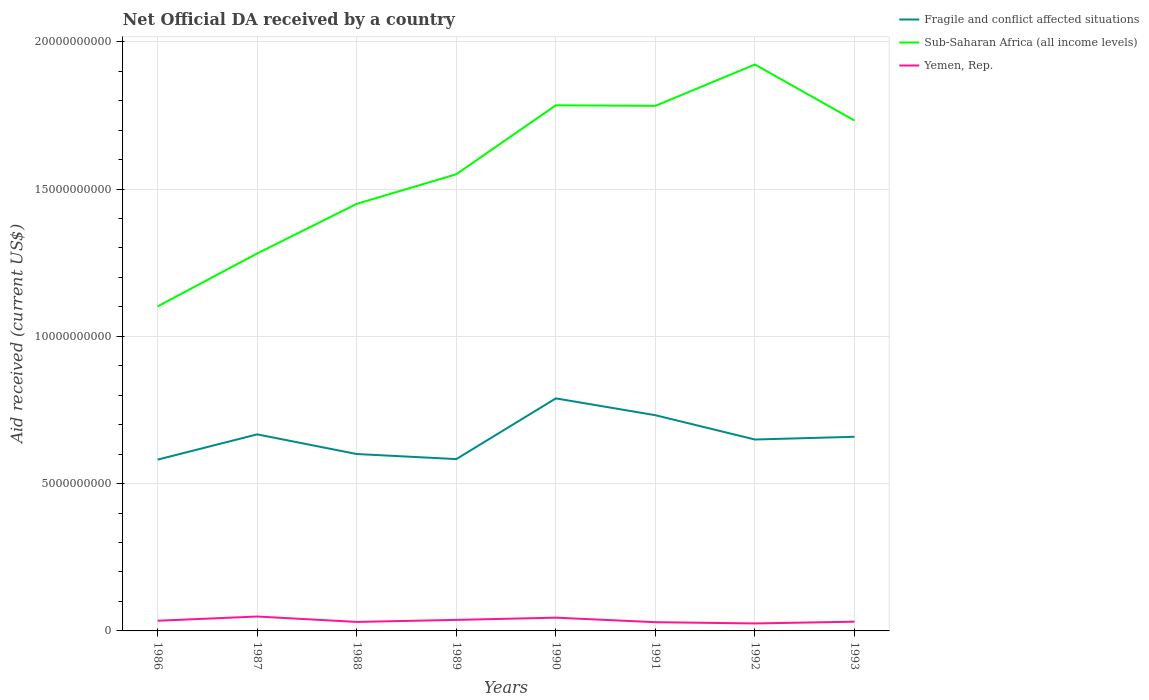How many different coloured lines are there?
Ensure brevity in your answer.  3. Does the line corresponding to Sub-Saharan Africa (all income levels) intersect with the line corresponding to Fragile and conflict affected situations?
Keep it short and to the point. No. Across all years, what is the maximum net official development assistance aid received in Yemen, Rep.?
Offer a terse response. 2.54e+08. What is the total net official development assistance aid received in Yemen, Rep. in the graph?
Offer a terse response. -2.85e+07. What is the difference between the highest and the second highest net official development assistance aid received in Fragile and conflict affected situations?
Your response must be concise. 2.08e+09. How many lines are there?
Provide a succinct answer. 3. Are the values on the major ticks of Y-axis written in scientific E-notation?
Offer a very short reply. No. Does the graph contain grids?
Your answer should be very brief. Yes. Where does the legend appear in the graph?
Make the answer very short. Top right. How many legend labels are there?
Your answer should be very brief. 3. What is the title of the graph?
Your response must be concise. Net Official DA received by a country. What is the label or title of the X-axis?
Make the answer very short. Years. What is the label or title of the Y-axis?
Keep it short and to the point. Aid received (current US$). What is the Aid received (current US$) in Fragile and conflict affected situations in 1986?
Ensure brevity in your answer.  5.81e+09. What is the Aid received (current US$) in Sub-Saharan Africa (all income levels) in 1986?
Ensure brevity in your answer.  1.10e+1. What is the Aid received (current US$) of Yemen, Rep. in 1986?
Give a very brief answer. 3.46e+08. What is the Aid received (current US$) in Fragile and conflict affected situations in 1987?
Offer a very short reply. 6.67e+09. What is the Aid received (current US$) of Sub-Saharan Africa (all income levels) in 1987?
Make the answer very short. 1.28e+1. What is the Aid received (current US$) of Yemen, Rep. in 1987?
Your answer should be compact. 4.89e+08. What is the Aid received (current US$) of Fragile and conflict affected situations in 1988?
Your response must be concise. 6.00e+09. What is the Aid received (current US$) of Sub-Saharan Africa (all income levels) in 1988?
Keep it short and to the point. 1.45e+1. What is the Aid received (current US$) of Yemen, Rep. in 1988?
Offer a very short reply. 3.05e+08. What is the Aid received (current US$) in Fragile and conflict affected situations in 1989?
Provide a succinct answer. 5.83e+09. What is the Aid received (current US$) in Sub-Saharan Africa (all income levels) in 1989?
Provide a succinct answer. 1.55e+1. What is the Aid received (current US$) of Yemen, Rep. in 1989?
Your answer should be very brief. 3.74e+08. What is the Aid received (current US$) of Fragile and conflict affected situations in 1990?
Provide a succinct answer. 7.89e+09. What is the Aid received (current US$) of Sub-Saharan Africa (all income levels) in 1990?
Your answer should be compact. 1.78e+1. What is the Aid received (current US$) in Yemen, Rep. in 1990?
Ensure brevity in your answer.  4.50e+08. What is the Aid received (current US$) in Fragile and conflict affected situations in 1991?
Your response must be concise. 7.32e+09. What is the Aid received (current US$) in Sub-Saharan Africa (all income levels) in 1991?
Make the answer very short. 1.78e+1. What is the Aid received (current US$) of Yemen, Rep. in 1991?
Your response must be concise. 2.96e+08. What is the Aid received (current US$) in Fragile and conflict affected situations in 1992?
Offer a very short reply. 6.50e+09. What is the Aid received (current US$) of Sub-Saharan Africa (all income levels) in 1992?
Give a very brief answer. 1.92e+1. What is the Aid received (current US$) of Yemen, Rep. in 1992?
Your answer should be very brief. 2.54e+08. What is the Aid received (current US$) in Fragile and conflict affected situations in 1993?
Your answer should be compact. 6.59e+09. What is the Aid received (current US$) in Sub-Saharan Africa (all income levels) in 1993?
Your answer should be very brief. 1.73e+1. What is the Aid received (current US$) in Yemen, Rep. in 1993?
Give a very brief answer. 3.13e+08. Across all years, what is the maximum Aid received (current US$) of Fragile and conflict affected situations?
Provide a succinct answer. 7.89e+09. Across all years, what is the maximum Aid received (current US$) of Sub-Saharan Africa (all income levels)?
Offer a terse response. 1.92e+1. Across all years, what is the maximum Aid received (current US$) in Yemen, Rep.?
Offer a very short reply. 4.89e+08. Across all years, what is the minimum Aid received (current US$) in Fragile and conflict affected situations?
Provide a succinct answer. 5.81e+09. Across all years, what is the minimum Aid received (current US$) in Sub-Saharan Africa (all income levels)?
Your answer should be compact. 1.10e+1. Across all years, what is the minimum Aid received (current US$) in Yemen, Rep.?
Make the answer very short. 2.54e+08. What is the total Aid received (current US$) of Fragile and conflict affected situations in the graph?
Your response must be concise. 5.26e+1. What is the total Aid received (current US$) of Sub-Saharan Africa (all income levels) in the graph?
Provide a succinct answer. 1.26e+11. What is the total Aid received (current US$) of Yemen, Rep. in the graph?
Offer a very short reply. 2.83e+09. What is the difference between the Aid received (current US$) in Fragile and conflict affected situations in 1986 and that in 1987?
Your answer should be compact. -8.57e+08. What is the difference between the Aid received (current US$) of Sub-Saharan Africa (all income levels) in 1986 and that in 1987?
Offer a terse response. -1.80e+09. What is the difference between the Aid received (current US$) of Yemen, Rep. in 1986 and that in 1987?
Your response must be concise. -1.43e+08. What is the difference between the Aid received (current US$) of Fragile and conflict affected situations in 1986 and that in 1988?
Make the answer very short. -1.89e+08. What is the difference between the Aid received (current US$) in Sub-Saharan Africa (all income levels) in 1986 and that in 1988?
Ensure brevity in your answer.  -3.48e+09. What is the difference between the Aid received (current US$) of Yemen, Rep. in 1986 and that in 1988?
Ensure brevity in your answer.  4.05e+07. What is the difference between the Aid received (current US$) of Fragile and conflict affected situations in 1986 and that in 1989?
Ensure brevity in your answer.  -1.72e+07. What is the difference between the Aid received (current US$) in Sub-Saharan Africa (all income levels) in 1986 and that in 1989?
Provide a succinct answer. -4.48e+09. What is the difference between the Aid received (current US$) in Yemen, Rep. in 1986 and that in 1989?
Your answer should be compact. -2.85e+07. What is the difference between the Aid received (current US$) of Fragile and conflict affected situations in 1986 and that in 1990?
Ensure brevity in your answer.  -2.08e+09. What is the difference between the Aid received (current US$) in Sub-Saharan Africa (all income levels) in 1986 and that in 1990?
Your answer should be very brief. -6.83e+09. What is the difference between the Aid received (current US$) in Yemen, Rep. in 1986 and that in 1990?
Keep it short and to the point. -1.04e+08. What is the difference between the Aid received (current US$) of Fragile and conflict affected situations in 1986 and that in 1991?
Give a very brief answer. -1.51e+09. What is the difference between the Aid received (current US$) of Sub-Saharan Africa (all income levels) in 1986 and that in 1991?
Your response must be concise. -6.81e+09. What is the difference between the Aid received (current US$) in Yemen, Rep. in 1986 and that in 1991?
Your answer should be very brief. 4.95e+07. What is the difference between the Aid received (current US$) of Fragile and conflict affected situations in 1986 and that in 1992?
Provide a short and direct response. -6.82e+08. What is the difference between the Aid received (current US$) in Sub-Saharan Africa (all income levels) in 1986 and that in 1992?
Offer a terse response. -8.21e+09. What is the difference between the Aid received (current US$) in Yemen, Rep. in 1986 and that in 1992?
Your response must be concise. 9.20e+07. What is the difference between the Aid received (current US$) in Fragile and conflict affected situations in 1986 and that in 1993?
Ensure brevity in your answer.  -7.75e+08. What is the difference between the Aid received (current US$) in Sub-Saharan Africa (all income levels) in 1986 and that in 1993?
Give a very brief answer. -6.31e+09. What is the difference between the Aid received (current US$) in Yemen, Rep. in 1986 and that in 1993?
Your answer should be compact. 3.26e+07. What is the difference between the Aid received (current US$) in Fragile and conflict affected situations in 1987 and that in 1988?
Make the answer very short. 6.68e+08. What is the difference between the Aid received (current US$) in Sub-Saharan Africa (all income levels) in 1987 and that in 1988?
Give a very brief answer. -1.68e+09. What is the difference between the Aid received (current US$) of Yemen, Rep. in 1987 and that in 1988?
Offer a terse response. 1.83e+08. What is the difference between the Aid received (current US$) in Fragile and conflict affected situations in 1987 and that in 1989?
Offer a terse response. 8.40e+08. What is the difference between the Aid received (current US$) in Sub-Saharan Africa (all income levels) in 1987 and that in 1989?
Ensure brevity in your answer.  -2.69e+09. What is the difference between the Aid received (current US$) in Yemen, Rep. in 1987 and that in 1989?
Provide a short and direct response. 1.14e+08. What is the difference between the Aid received (current US$) in Fragile and conflict affected situations in 1987 and that in 1990?
Ensure brevity in your answer.  -1.22e+09. What is the difference between the Aid received (current US$) in Sub-Saharan Africa (all income levels) in 1987 and that in 1990?
Offer a terse response. -5.03e+09. What is the difference between the Aid received (current US$) in Yemen, Rep. in 1987 and that in 1990?
Your response must be concise. 3.89e+07. What is the difference between the Aid received (current US$) in Fragile and conflict affected situations in 1987 and that in 1991?
Ensure brevity in your answer.  -6.50e+08. What is the difference between the Aid received (current US$) of Sub-Saharan Africa (all income levels) in 1987 and that in 1991?
Make the answer very short. -5.01e+09. What is the difference between the Aid received (current US$) in Yemen, Rep. in 1987 and that in 1991?
Make the answer very short. 1.92e+08. What is the difference between the Aid received (current US$) in Fragile and conflict affected situations in 1987 and that in 1992?
Your response must be concise. 1.75e+08. What is the difference between the Aid received (current US$) of Sub-Saharan Africa (all income levels) in 1987 and that in 1992?
Ensure brevity in your answer.  -6.41e+09. What is the difference between the Aid received (current US$) of Yemen, Rep. in 1987 and that in 1992?
Your answer should be compact. 2.35e+08. What is the difference between the Aid received (current US$) in Fragile and conflict affected situations in 1987 and that in 1993?
Give a very brief answer. 8.20e+07. What is the difference between the Aid received (current US$) of Sub-Saharan Africa (all income levels) in 1987 and that in 1993?
Ensure brevity in your answer.  -4.51e+09. What is the difference between the Aid received (current US$) in Yemen, Rep. in 1987 and that in 1993?
Give a very brief answer. 1.76e+08. What is the difference between the Aid received (current US$) in Fragile and conflict affected situations in 1988 and that in 1989?
Offer a terse response. 1.72e+08. What is the difference between the Aid received (current US$) of Sub-Saharan Africa (all income levels) in 1988 and that in 1989?
Provide a succinct answer. -1.00e+09. What is the difference between the Aid received (current US$) of Yemen, Rep. in 1988 and that in 1989?
Your response must be concise. -6.89e+07. What is the difference between the Aid received (current US$) in Fragile and conflict affected situations in 1988 and that in 1990?
Your answer should be very brief. -1.89e+09. What is the difference between the Aid received (current US$) of Sub-Saharan Africa (all income levels) in 1988 and that in 1990?
Give a very brief answer. -3.35e+09. What is the difference between the Aid received (current US$) in Yemen, Rep. in 1988 and that in 1990?
Your answer should be compact. -1.44e+08. What is the difference between the Aid received (current US$) in Fragile and conflict affected situations in 1988 and that in 1991?
Ensure brevity in your answer.  -1.32e+09. What is the difference between the Aid received (current US$) of Sub-Saharan Africa (all income levels) in 1988 and that in 1991?
Make the answer very short. -3.33e+09. What is the difference between the Aid received (current US$) of Yemen, Rep. in 1988 and that in 1991?
Make the answer very short. 9.00e+06. What is the difference between the Aid received (current US$) of Fragile and conflict affected situations in 1988 and that in 1992?
Offer a terse response. -4.93e+08. What is the difference between the Aid received (current US$) in Sub-Saharan Africa (all income levels) in 1988 and that in 1992?
Offer a terse response. -4.73e+09. What is the difference between the Aid received (current US$) in Yemen, Rep. in 1988 and that in 1992?
Keep it short and to the point. 5.16e+07. What is the difference between the Aid received (current US$) in Fragile and conflict affected situations in 1988 and that in 1993?
Provide a short and direct response. -5.86e+08. What is the difference between the Aid received (current US$) of Sub-Saharan Africa (all income levels) in 1988 and that in 1993?
Ensure brevity in your answer.  -2.83e+09. What is the difference between the Aid received (current US$) in Yemen, Rep. in 1988 and that in 1993?
Offer a terse response. -7.83e+06. What is the difference between the Aid received (current US$) in Fragile and conflict affected situations in 1989 and that in 1990?
Offer a terse response. -2.06e+09. What is the difference between the Aid received (current US$) of Sub-Saharan Africa (all income levels) in 1989 and that in 1990?
Provide a succinct answer. -2.34e+09. What is the difference between the Aid received (current US$) of Yemen, Rep. in 1989 and that in 1990?
Give a very brief answer. -7.56e+07. What is the difference between the Aid received (current US$) in Fragile and conflict affected situations in 1989 and that in 1991?
Provide a succinct answer. -1.49e+09. What is the difference between the Aid received (current US$) of Sub-Saharan Africa (all income levels) in 1989 and that in 1991?
Your response must be concise. -2.32e+09. What is the difference between the Aid received (current US$) in Yemen, Rep. in 1989 and that in 1991?
Ensure brevity in your answer.  7.79e+07. What is the difference between the Aid received (current US$) of Fragile and conflict affected situations in 1989 and that in 1992?
Your answer should be very brief. -6.65e+08. What is the difference between the Aid received (current US$) in Sub-Saharan Africa (all income levels) in 1989 and that in 1992?
Your answer should be very brief. -3.72e+09. What is the difference between the Aid received (current US$) in Yemen, Rep. in 1989 and that in 1992?
Ensure brevity in your answer.  1.21e+08. What is the difference between the Aid received (current US$) in Fragile and conflict affected situations in 1989 and that in 1993?
Provide a succinct answer. -7.58e+08. What is the difference between the Aid received (current US$) of Sub-Saharan Africa (all income levels) in 1989 and that in 1993?
Make the answer very short. -1.82e+09. What is the difference between the Aid received (current US$) of Yemen, Rep. in 1989 and that in 1993?
Offer a terse response. 6.11e+07. What is the difference between the Aid received (current US$) of Fragile and conflict affected situations in 1990 and that in 1991?
Offer a very short reply. 5.70e+08. What is the difference between the Aid received (current US$) of Sub-Saharan Africa (all income levels) in 1990 and that in 1991?
Make the answer very short. 1.91e+07. What is the difference between the Aid received (current US$) in Yemen, Rep. in 1990 and that in 1991?
Your answer should be very brief. 1.53e+08. What is the difference between the Aid received (current US$) in Fragile and conflict affected situations in 1990 and that in 1992?
Your response must be concise. 1.40e+09. What is the difference between the Aid received (current US$) in Sub-Saharan Africa (all income levels) in 1990 and that in 1992?
Provide a succinct answer. -1.38e+09. What is the difference between the Aid received (current US$) in Yemen, Rep. in 1990 and that in 1992?
Keep it short and to the point. 1.96e+08. What is the difference between the Aid received (current US$) of Fragile and conflict affected situations in 1990 and that in 1993?
Provide a short and direct response. 1.30e+09. What is the difference between the Aid received (current US$) in Sub-Saharan Africa (all income levels) in 1990 and that in 1993?
Keep it short and to the point. 5.17e+08. What is the difference between the Aid received (current US$) in Yemen, Rep. in 1990 and that in 1993?
Your response must be concise. 1.37e+08. What is the difference between the Aid received (current US$) of Fragile and conflict affected situations in 1991 and that in 1992?
Make the answer very short. 8.25e+08. What is the difference between the Aid received (current US$) in Sub-Saharan Africa (all income levels) in 1991 and that in 1992?
Your answer should be very brief. -1.40e+09. What is the difference between the Aid received (current US$) of Yemen, Rep. in 1991 and that in 1992?
Make the answer very short. 4.26e+07. What is the difference between the Aid received (current US$) of Fragile and conflict affected situations in 1991 and that in 1993?
Offer a terse response. 7.32e+08. What is the difference between the Aid received (current US$) in Sub-Saharan Africa (all income levels) in 1991 and that in 1993?
Give a very brief answer. 4.98e+08. What is the difference between the Aid received (current US$) of Yemen, Rep. in 1991 and that in 1993?
Your response must be concise. -1.68e+07. What is the difference between the Aid received (current US$) of Fragile and conflict affected situations in 1992 and that in 1993?
Keep it short and to the point. -9.26e+07. What is the difference between the Aid received (current US$) of Sub-Saharan Africa (all income levels) in 1992 and that in 1993?
Your answer should be compact. 1.90e+09. What is the difference between the Aid received (current US$) of Yemen, Rep. in 1992 and that in 1993?
Your response must be concise. -5.94e+07. What is the difference between the Aid received (current US$) in Fragile and conflict affected situations in 1986 and the Aid received (current US$) in Sub-Saharan Africa (all income levels) in 1987?
Provide a succinct answer. -7.00e+09. What is the difference between the Aid received (current US$) of Fragile and conflict affected situations in 1986 and the Aid received (current US$) of Yemen, Rep. in 1987?
Your response must be concise. 5.33e+09. What is the difference between the Aid received (current US$) in Sub-Saharan Africa (all income levels) in 1986 and the Aid received (current US$) in Yemen, Rep. in 1987?
Your answer should be very brief. 1.05e+1. What is the difference between the Aid received (current US$) of Fragile and conflict affected situations in 1986 and the Aid received (current US$) of Sub-Saharan Africa (all income levels) in 1988?
Keep it short and to the point. -8.68e+09. What is the difference between the Aid received (current US$) of Fragile and conflict affected situations in 1986 and the Aid received (current US$) of Yemen, Rep. in 1988?
Your answer should be compact. 5.51e+09. What is the difference between the Aid received (current US$) of Sub-Saharan Africa (all income levels) in 1986 and the Aid received (current US$) of Yemen, Rep. in 1988?
Offer a very short reply. 1.07e+1. What is the difference between the Aid received (current US$) in Fragile and conflict affected situations in 1986 and the Aid received (current US$) in Sub-Saharan Africa (all income levels) in 1989?
Keep it short and to the point. -9.69e+09. What is the difference between the Aid received (current US$) of Fragile and conflict affected situations in 1986 and the Aid received (current US$) of Yemen, Rep. in 1989?
Make the answer very short. 5.44e+09. What is the difference between the Aid received (current US$) in Sub-Saharan Africa (all income levels) in 1986 and the Aid received (current US$) in Yemen, Rep. in 1989?
Provide a succinct answer. 1.06e+1. What is the difference between the Aid received (current US$) in Fragile and conflict affected situations in 1986 and the Aid received (current US$) in Sub-Saharan Africa (all income levels) in 1990?
Offer a very short reply. -1.20e+1. What is the difference between the Aid received (current US$) in Fragile and conflict affected situations in 1986 and the Aid received (current US$) in Yemen, Rep. in 1990?
Your answer should be very brief. 5.37e+09. What is the difference between the Aid received (current US$) of Sub-Saharan Africa (all income levels) in 1986 and the Aid received (current US$) of Yemen, Rep. in 1990?
Ensure brevity in your answer.  1.06e+1. What is the difference between the Aid received (current US$) of Fragile and conflict affected situations in 1986 and the Aid received (current US$) of Sub-Saharan Africa (all income levels) in 1991?
Ensure brevity in your answer.  -1.20e+1. What is the difference between the Aid received (current US$) of Fragile and conflict affected situations in 1986 and the Aid received (current US$) of Yemen, Rep. in 1991?
Your answer should be very brief. 5.52e+09. What is the difference between the Aid received (current US$) of Sub-Saharan Africa (all income levels) in 1986 and the Aid received (current US$) of Yemen, Rep. in 1991?
Offer a very short reply. 1.07e+1. What is the difference between the Aid received (current US$) of Fragile and conflict affected situations in 1986 and the Aid received (current US$) of Sub-Saharan Africa (all income levels) in 1992?
Provide a succinct answer. -1.34e+1. What is the difference between the Aid received (current US$) in Fragile and conflict affected situations in 1986 and the Aid received (current US$) in Yemen, Rep. in 1992?
Your answer should be very brief. 5.56e+09. What is the difference between the Aid received (current US$) in Sub-Saharan Africa (all income levels) in 1986 and the Aid received (current US$) in Yemen, Rep. in 1992?
Your answer should be compact. 1.08e+1. What is the difference between the Aid received (current US$) in Fragile and conflict affected situations in 1986 and the Aid received (current US$) in Sub-Saharan Africa (all income levels) in 1993?
Keep it short and to the point. -1.15e+1. What is the difference between the Aid received (current US$) of Fragile and conflict affected situations in 1986 and the Aid received (current US$) of Yemen, Rep. in 1993?
Give a very brief answer. 5.50e+09. What is the difference between the Aid received (current US$) in Sub-Saharan Africa (all income levels) in 1986 and the Aid received (current US$) in Yemen, Rep. in 1993?
Your answer should be very brief. 1.07e+1. What is the difference between the Aid received (current US$) of Fragile and conflict affected situations in 1987 and the Aid received (current US$) of Sub-Saharan Africa (all income levels) in 1988?
Ensure brevity in your answer.  -7.82e+09. What is the difference between the Aid received (current US$) in Fragile and conflict affected situations in 1987 and the Aid received (current US$) in Yemen, Rep. in 1988?
Provide a succinct answer. 6.37e+09. What is the difference between the Aid received (current US$) in Sub-Saharan Africa (all income levels) in 1987 and the Aid received (current US$) in Yemen, Rep. in 1988?
Ensure brevity in your answer.  1.25e+1. What is the difference between the Aid received (current US$) of Fragile and conflict affected situations in 1987 and the Aid received (current US$) of Sub-Saharan Africa (all income levels) in 1989?
Offer a terse response. -8.83e+09. What is the difference between the Aid received (current US$) in Fragile and conflict affected situations in 1987 and the Aid received (current US$) in Yemen, Rep. in 1989?
Provide a short and direct response. 6.30e+09. What is the difference between the Aid received (current US$) of Sub-Saharan Africa (all income levels) in 1987 and the Aid received (current US$) of Yemen, Rep. in 1989?
Offer a terse response. 1.24e+1. What is the difference between the Aid received (current US$) of Fragile and conflict affected situations in 1987 and the Aid received (current US$) of Sub-Saharan Africa (all income levels) in 1990?
Your answer should be compact. -1.12e+1. What is the difference between the Aid received (current US$) in Fragile and conflict affected situations in 1987 and the Aid received (current US$) in Yemen, Rep. in 1990?
Keep it short and to the point. 6.22e+09. What is the difference between the Aid received (current US$) of Sub-Saharan Africa (all income levels) in 1987 and the Aid received (current US$) of Yemen, Rep. in 1990?
Your response must be concise. 1.24e+1. What is the difference between the Aid received (current US$) in Fragile and conflict affected situations in 1987 and the Aid received (current US$) in Sub-Saharan Africa (all income levels) in 1991?
Provide a succinct answer. -1.12e+1. What is the difference between the Aid received (current US$) of Fragile and conflict affected situations in 1987 and the Aid received (current US$) of Yemen, Rep. in 1991?
Ensure brevity in your answer.  6.38e+09. What is the difference between the Aid received (current US$) in Sub-Saharan Africa (all income levels) in 1987 and the Aid received (current US$) in Yemen, Rep. in 1991?
Your response must be concise. 1.25e+1. What is the difference between the Aid received (current US$) in Fragile and conflict affected situations in 1987 and the Aid received (current US$) in Sub-Saharan Africa (all income levels) in 1992?
Provide a short and direct response. -1.26e+1. What is the difference between the Aid received (current US$) in Fragile and conflict affected situations in 1987 and the Aid received (current US$) in Yemen, Rep. in 1992?
Offer a terse response. 6.42e+09. What is the difference between the Aid received (current US$) in Sub-Saharan Africa (all income levels) in 1987 and the Aid received (current US$) in Yemen, Rep. in 1992?
Keep it short and to the point. 1.26e+1. What is the difference between the Aid received (current US$) in Fragile and conflict affected situations in 1987 and the Aid received (current US$) in Sub-Saharan Africa (all income levels) in 1993?
Your response must be concise. -1.07e+1. What is the difference between the Aid received (current US$) in Fragile and conflict affected situations in 1987 and the Aid received (current US$) in Yemen, Rep. in 1993?
Offer a terse response. 6.36e+09. What is the difference between the Aid received (current US$) of Sub-Saharan Africa (all income levels) in 1987 and the Aid received (current US$) of Yemen, Rep. in 1993?
Your answer should be compact. 1.25e+1. What is the difference between the Aid received (current US$) in Fragile and conflict affected situations in 1988 and the Aid received (current US$) in Sub-Saharan Africa (all income levels) in 1989?
Your answer should be very brief. -9.50e+09. What is the difference between the Aid received (current US$) of Fragile and conflict affected situations in 1988 and the Aid received (current US$) of Yemen, Rep. in 1989?
Make the answer very short. 5.63e+09. What is the difference between the Aid received (current US$) of Sub-Saharan Africa (all income levels) in 1988 and the Aid received (current US$) of Yemen, Rep. in 1989?
Offer a terse response. 1.41e+1. What is the difference between the Aid received (current US$) of Fragile and conflict affected situations in 1988 and the Aid received (current US$) of Sub-Saharan Africa (all income levels) in 1990?
Make the answer very short. -1.18e+1. What is the difference between the Aid received (current US$) in Fragile and conflict affected situations in 1988 and the Aid received (current US$) in Yemen, Rep. in 1990?
Your answer should be compact. 5.55e+09. What is the difference between the Aid received (current US$) in Sub-Saharan Africa (all income levels) in 1988 and the Aid received (current US$) in Yemen, Rep. in 1990?
Your response must be concise. 1.40e+1. What is the difference between the Aid received (current US$) in Fragile and conflict affected situations in 1988 and the Aid received (current US$) in Sub-Saharan Africa (all income levels) in 1991?
Provide a succinct answer. -1.18e+1. What is the difference between the Aid received (current US$) in Fragile and conflict affected situations in 1988 and the Aid received (current US$) in Yemen, Rep. in 1991?
Ensure brevity in your answer.  5.71e+09. What is the difference between the Aid received (current US$) of Sub-Saharan Africa (all income levels) in 1988 and the Aid received (current US$) of Yemen, Rep. in 1991?
Your response must be concise. 1.42e+1. What is the difference between the Aid received (current US$) in Fragile and conflict affected situations in 1988 and the Aid received (current US$) in Sub-Saharan Africa (all income levels) in 1992?
Your answer should be compact. -1.32e+1. What is the difference between the Aid received (current US$) of Fragile and conflict affected situations in 1988 and the Aid received (current US$) of Yemen, Rep. in 1992?
Ensure brevity in your answer.  5.75e+09. What is the difference between the Aid received (current US$) of Sub-Saharan Africa (all income levels) in 1988 and the Aid received (current US$) of Yemen, Rep. in 1992?
Make the answer very short. 1.42e+1. What is the difference between the Aid received (current US$) in Fragile and conflict affected situations in 1988 and the Aid received (current US$) in Sub-Saharan Africa (all income levels) in 1993?
Provide a short and direct response. -1.13e+1. What is the difference between the Aid received (current US$) of Fragile and conflict affected situations in 1988 and the Aid received (current US$) of Yemen, Rep. in 1993?
Ensure brevity in your answer.  5.69e+09. What is the difference between the Aid received (current US$) in Sub-Saharan Africa (all income levels) in 1988 and the Aid received (current US$) in Yemen, Rep. in 1993?
Give a very brief answer. 1.42e+1. What is the difference between the Aid received (current US$) in Fragile and conflict affected situations in 1989 and the Aid received (current US$) in Sub-Saharan Africa (all income levels) in 1990?
Offer a very short reply. -1.20e+1. What is the difference between the Aid received (current US$) of Fragile and conflict affected situations in 1989 and the Aid received (current US$) of Yemen, Rep. in 1990?
Make the answer very short. 5.38e+09. What is the difference between the Aid received (current US$) of Sub-Saharan Africa (all income levels) in 1989 and the Aid received (current US$) of Yemen, Rep. in 1990?
Offer a terse response. 1.51e+1. What is the difference between the Aid received (current US$) in Fragile and conflict affected situations in 1989 and the Aid received (current US$) in Sub-Saharan Africa (all income levels) in 1991?
Your answer should be compact. -1.20e+1. What is the difference between the Aid received (current US$) of Fragile and conflict affected situations in 1989 and the Aid received (current US$) of Yemen, Rep. in 1991?
Give a very brief answer. 5.54e+09. What is the difference between the Aid received (current US$) in Sub-Saharan Africa (all income levels) in 1989 and the Aid received (current US$) in Yemen, Rep. in 1991?
Provide a short and direct response. 1.52e+1. What is the difference between the Aid received (current US$) in Fragile and conflict affected situations in 1989 and the Aid received (current US$) in Sub-Saharan Africa (all income levels) in 1992?
Offer a terse response. -1.34e+1. What is the difference between the Aid received (current US$) of Fragile and conflict affected situations in 1989 and the Aid received (current US$) of Yemen, Rep. in 1992?
Offer a terse response. 5.58e+09. What is the difference between the Aid received (current US$) in Sub-Saharan Africa (all income levels) in 1989 and the Aid received (current US$) in Yemen, Rep. in 1992?
Keep it short and to the point. 1.52e+1. What is the difference between the Aid received (current US$) in Fragile and conflict affected situations in 1989 and the Aid received (current US$) in Sub-Saharan Africa (all income levels) in 1993?
Provide a short and direct response. -1.15e+1. What is the difference between the Aid received (current US$) in Fragile and conflict affected situations in 1989 and the Aid received (current US$) in Yemen, Rep. in 1993?
Your response must be concise. 5.52e+09. What is the difference between the Aid received (current US$) in Sub-Saharan Africa (all income levels) in 1989 and the Aid received (current US$) in Yemen, Rep. in 1993?
Ensure brevity in your answer.  1.52e+1. What is the difference between the Aid received (current US$) in Fragile and conflict affected situations in 1990 and the Aid received (current US$) in Sub-Saharan Africa (all income levels) in 1991?
Your response must be concise. -9.93e+09. What is the difference between the Aid received (current US$) in Fragile and conflict affected situations in 1990 and the Aid received (current US$) in Yemen, Rep. in 1991?
Make the answer very short. 7.60e+09. What is the difference between the Aid received (current US$) in Sub-Saharan Africa (all income levels) in 1990 and the Aid received (current US$) in Yemen, Rep. in 1991?
Keep it short and to the point. 1.75e+1. What is the difference between the Aid received (current US$) in Fragile and conflict affected situations in 1990 and the Aid received (current US$) in Sub-Saharan Africa (all income levels) in 1992?
Your response must be concise. -1.13e+1. What is the difference between the Aid received (current US$) of Fragile and conflict affected situations in 1990 and the Aid received (current US$) of Yemen, Rep. in 1992?
Your answer should be compact. 7.64e+09. What is the difference between the Aid received (current US$) in Sub-Saharan Africa (all income levels) in 1990 and the Aid received (current US$) in Yemen, Rep. in 1992?
Provide a succinct answer. 1.76e+1. What is the difference between the Aid received (current US$) in Fragile and conflict affected situations in 1990 and the Aid received (current US$) in Sub-Saharan Africa (all income levels) in 1993?
Offer a terse response. -9.43e+09. What is the difference between the Aid received (current US$) in Fragile and conflict affected situations in 1990 and the Aid received (current US$) in Yemen, Rep. in 1993?
Keep it short and to the point. 7.58e+09. What is the difference between the Aid received (current US$) in Sub-Saharan Africa (all income levels) in 1990 and the Aid received (current US$) in Yemen, Rep. in 1993?
Provide a succinct answer. 1.75e+1. What is the difference between the Aid received (current US$) of Fragile and conflict affected situations in 1991 and the Aid received (current US$) of Sub-Saharan Africa (all income levels) in 1992?
Keep it short and to the point. -1.19e+1. What is the difference between the Aid received (current US$) of Fragile and conflict affected situations in 1991 and the Aid received (current US$) of Yemen, Rep. in 1992?
Offer a terse response. 7.07e+09. What is the difference between the Aid received (current US$) of Sub-Saharan Africa (all income levels) in 1991 and the Aid received (current US$) of Yemen, Rep. in 1992?
Provide a short and direct response. 1.76e+1. What is the difference between the Aid received (current US$) in Fragile and conflict affected situations in 1991 and the Aid received (current US$) in Sub-Saharan Africa (all income levels) in 1993?
Keep it short and to the point. -1.00e+1. What is the difference between the Aid received (current US$) of Fragile and conflict affected situations in 1991 and the Aid received (current US$) of Yemen, Rep. in 1993?
Offer a very short reply. 7.01e+09. What is the difference between the Aid received (current US$) of Sub-Saharan Africa (all income levels) in 1991 and the Aid received (current US$) of Yemen, Rep. in 1993?
Make the answer very short. 1.75e+1. What is the difference between the Aid received (current US$) in Fragile and conflict affected situations in 1992 and the Aid received (current US$) in Sub-Saharan Africa (all income levels) in 1993?
Offer a terse response. -1.08e+1. What is the difference between the Aid received (current US$) of Fragile and conflict affected situations in 1992 and the Aid received (current US$) of Yemen, Rep. in 1993?
Give a very brief answer. 6.18e+09. What is the difference between the Aid received (current US$) in Sub-Saharan Africa (all income levels) in 1992 and the Aid received (current US$) in Yemen, Rep. in 1993?
Offer a very short reply. 1.89e+1. What is the average Aid received (current US$) in Fragile and conflict affected situations per year?
Provide a short and direct response. 6.58e+09. What is the average Aid received (current US$) in Sub-Saharan Africa (all income levels) per year?
Your answer should be very brief. 1.58e+1. What is the average Aid received (current US$) of Yemen, Rep. per year?
Make the answer very short. 3.53e+08. In the year 1986, what is the difference between the Aid received (current US$) of Fragile and conflict affected situations and Aid received (current US$) of Sub-Saharan Africa (all income levels)?
Give a very brief answer. -5.20e+09. In the year 1986, what is the difference between the Aid received (current US$) in Fragile and conflict affected situations and Aid received (current US$) in Yemen, Rep.?
Provide a succinct answer. 5.47e+09. In the year 1986, what is the difference between the Aid received (current US$) in Sub-Saharan Africa (all income levels) and Aid received (current US$) in Yemen, Rep.?
Offer a very short reply. 1.07e+1. In the year 1987, what is the difference between the Aid received (current US$) of Fragile and conflict affected situations and Aid received (current US$) of Sub-Saharan Africa (all income levels)?
Provide a succinct answer. -6.14e+09. In the year 1987, what is the difference between the Aid received (current US$) in Fragile and conflict affected situations and Aid received (current US$) in Yemen, Rep.?
Give a very brief answer. 6.18e+09. In the year 1987, what is the difference between the Aid received (current US$) in Sub-Saharan Africa (all income levels) and Aid received (current US$) in Yemen, Rep.?
Provide a succinct answer. 1.23e+1. In the year 1988, what is the difference between the Aid received (current US$) in Fragile and conflict affected situations and Aid received (current US$) in Sub-Saharan Africa (all income levels)?
Give a very brief answer. -8.49e+09. In the year 1988, what is the difference between the Aid received (current US$) in Fragile and conflict affected situations and Aid received (current US$) in Yemen, Rep.?
Provide a succinct answer. 5.70e+09. In the year 1988, what is the difference between the Aid received (current US$) of Sub-Saharan Africa (all income levels) and Aid received (current US$) of Yemen, Rep.?
Offer a very short reply. 1.42e+1. In the year 1989, what is the difference between the Aid received (current US$) in Fragile and conflict affected situations and Aid received (current US$) in Sub-Saharan Africa (all income levels)?
Your response must be concise. -9.67e+09. In the year 1989, what is the difference between the Aid received (current US$) in Fragile and conflict affected situations and Aid received (current US$) in Yemen, Rep.?
Provide a short and direct response. 5.46e+09. In the year 1989, what is the difference between the Aid received (current US$) of Sub-Saharan Africa (all income levels) and Aid received (current US$) of Yemen, Rep.?
Your response must be concise. 1.51e+1. In the year 1990, what is the difference between the Aid received (current US$) of Fragile and conflict affected situations and Aid received (current US$) of Sub-Saharan Africa (all income levels)?
Your answer should be very brief. -9.95e+09. In the year 1990, what is the difference between the Aid received (current US$) of Fragile and conflict affected situations and Aid received (current US$) of Yemen, Rep.?
Ensure brevity in your answer.  7.44e+09. In the year 1990, what is the difference between the Aid received (current US$) of Sub-Saharan Africa (all income levels) and Aid received (current US$) of Yemen, Rep.?
Provide a short and direct response. 1.74e+1. In the year 1991, what is the difference between the Aid received (current US$) of Fragile and conflict affected situations and Aid received (current US$) of Sub-Saharan Africa (all income levels)?
Your response must be concise. -1.05e+1. In the year 1991, what is the difference between the Aid received (current US$) of Fragile and conflict affected situations and Aid received (current US$) of Yemen, Rep.?
Ensure brevity in your answer.  7.03e+09. In the year 1991, what is the difference between the Aid received (current US$) in Sub-Saharan Africa (all income levels) and Aid received (current US$) in Yemen, Rep.?
Keep it short and to the point. 1.75e+1. In the year 1992, what is the difference between the Aid received (current US$) in Fragile and conflict affected situations and Aid received (current US$) in Sub-Saharan Africa (all income levels)?
Offer a terse response. -1.27e+1. In the year 1992, what is the difference between the Aid received (current US$) of Fragile and conflict affected situations and Aid received (current US$) of Yemen, Rep.?
Provide a succinct answer. 6.24e+09. In the year 1992, what is the difference between the Aid received (current US$) in Sub-Saharan Africa (all income levels) and Aid received (current US$) in Yemen, Rep.?
Make the answer very short. 1.90e+1. In the year 1993, what is the difference between the Aid received (current US$) of Fragile and conflict affected situations and Aid received (current US$) of Sub-Saharan Africa (all income levels)?
Your response must be concise. -1.07e+1. In the year 1993, what is the difference between the Aid received (current US$) in Fragile and conflict affected situations and Aid received (current US$) in Yemen, Rep.?
Offer a very short reply. 6.28e+09. In the year 1993, what is the difference between the Aid received (current US$) in Sub-Saharan Africa (all income levels) and Aid received (current US$) in Yemen, Rep.?
Your answer should be compact. 1.70e+1. What is the ratio of the Aid received (current US$) of Fragile and conflict affected situations in 1986 to that in 1987?
Give a very brief answer. 0.87. What is the ratio of the Aid received (current US$) in Sub-Saharan Africa (all income levels) in 1986 to that in 1987?
Offer a very short reply. 0.86. What is the ratio of the Aid received (current US$) in Yemen, Rep. in 1986 to that in 1987?
Give a very brief answer. 0.71. What is the ratio of the Aid received (current US$) in Fragile and conflict affected situations in 1986 to that in 1988?
Give a very brief answer. 0.97. What is the ratio of the Aid received (current US$) of Sub-Saharan Africa (all income levels) in 1986 to that in 1988?
Offer a very short reply. 0.76. What is the ratio of the Aid received (current US$) of Yemen, Rep. in 1986 to that in 1988?
Provide a succinct answer. 1.13. What is the ratio of the Aid received (current US$) of Sub-Saharan Africa (all income levels) in 1986 to that in 1989?
Offer a terse response. 0.71. What is the ratio of the Aid received (current US$) in Yemen, Rep. in 1986 to that in 1989?
Keep it short and to the point. 0.92. What is the ratio of the Aid received (current US$) in Fragile and conflict affected situations in 1986 to that in 1990?
Keep it short and to the point. 0.74. What is the ratio of the Aid received (current US$) in Sub-Saharan Africa (all income levels) in 1986 to that in 1990?
Your answer should be compact. 0.62. What is the ratio of the Aid received (current US$) in Yemen, Rep. in 1986 to that in 1990?
Offer a terse response. 0.77. What is the ratio of the Aid received (current US$) of Fragile and conflict affected situations in 1986 to that in 1991?
Ensure brevity in your answer.  0.79. What is the ratio of the Aid received (current US$) of Sub-Saharan Africa (all income levels) in 1986 to that in 1991?
Make the answer very short. 0.62. What is the ratio of the Aid received (current US$) in Yemen, Rep. in 1986 to that in 1991?
Offer a terse response. 1.17. What is the ratio of the Aid received (current US$) in Fragile and conflict affected situations in 1986 to that in 1992?
Ensure brevity in your answer.  0.9. What is the ratio of the Aid received (current US$) in Sub-Saharan Africa (all income levels) in 1986 to that in 1992?
Give a very brief answer. 0.57. What is the ratio of the Aid received (current US$) in Yemen, Rep. in 1986 to that in 1992?
Your response must be concise. 1.36. What is the ratio of the Aid received (current US$) in Fragile and conflict affected situations in 1986 to that in 1993?
Give a very brief answer. 0.88. What is the ratio of the Aid received (current US$) in Sub-Saharan Africa (all income levels) in 1986 to that in 1993?
Ensure brevity in your answer.  0.64. What is the ratio of the Aid received (current US$) in Yemen, Rep. in 1986 to that in 1993?
Make the answer very short. 1.1. What is the ratio of the Aid received (current US$) of Fragile and conflict affected situations in 1987 to that in 1988?
Your answer should be very brief. 1.11. What is the ratio of the Aid received (current US$) in Sub-Saharan Africa (all income levels) in 1987 to that in 1988?
Your answer should be very brief. 0.88. What is the ratio of the Aid received (current US$) of Yemen, Rep. in 1987 to that in 1988?
Make the answer very short. 1.6. What is the ratio of the Aid received (current US$) of Fragile and conflict affected situations in 1987 to that in 1989?
Keep it short and to the point. 1.14. What is the ratio of the Aid received (current US$) in Sub-Saharan Africa (all income levels) in 1987 to that in 1989?
Your answer should be very brief. 0.83. What is the ratio of the Aid received (current US$) in Yemen, Rep. in 1987 to that in 1989?
Offer a terse response. 1.31. What is the ratio of the Aid received (current US$) of Fragile and conflict affected situations in 1987 to that in 1990?
Keep it short and to the point. 0.85. What is the ratio of the Aid received (current US$) in Sub-Saharan Africa (all income levels) in 1987 to that in 1990?
Provide a short and direct response. 0.72. What is the ratio of the Aid received (current US$) of Yemen, Rep. in 1987 to that in 1990?
Make the answer very short. 1.09. What is the ratio of the Aid received (current US$) of Fragile and conflict affected situations in 1987 to that in 1991?
Provide a succinct answer. 0.91. What is the ratio of the Aid received (current US$) in Sub-Saharan Africa (all income levels) in 1987 to that in 1991?
Keep it short and to the point. 0.72. What is the ratio of the Aid received (current US$) in Yemen, Rep. in 1987 to that in 1991?
Make the answer very short. 1.65. What is the ratio of the Aid received (current US$) in Fragile and conflict affected situations in 1987 to that in 1992?
Ensure brevity in your answer.  1.03. What is the ratio of the Aid received (current US$) in Sub-Saharan Africa (all income levels) in 1987 to that in 1992?
Make the answer very short. 0.67. What is the ratio of the Aid received (current US$) of Yemen, Rep. in 1987 to that in 1992?
Make the answer very short. 1.93. What is the ratio of the Aid received (current US$) in Fragile and conflict affected situations in 1987 to that in 1993?
Give a very brief answer. 1.01. What is the ratio of the Aid received (current US$) of Sub-Saharan Africa (all income levels) in 1987 to that in 1993?
Your response must be concise. 0.74. What is the ratio of the Aid received (current US$) in Yemen, Rep. in 1987 to that in 1993?
Give a very brief answer. 1.56. What is the ratio of the Aid received (current US$) of Fragile and conflict affected situations in 1988 to that in 1989?
Keep it short and to the point. 1.03. What is the ratio of the Aid received (current US$) of Sub-Saharan Africa (all income levels) in 1988 to that in 1989?
Offer a very short reply. 0.94. What is the ratio of the Aid received (current US$) of Yemen, Rep. in 1988 to that in 1989?
Provide a succinct answer. 0.82. What is the ratio of the Aid received (current US$) of Fragile and conflict affected situations in 1988 to that in 1990?
Ensure brevity in your answer.  0.76. What is the ratio of the Aid received (current US$) of Sub-Saharan Africa (all income levels) in 1988 to that in 1990?
Your response must be concise. 0.81. What is the ratio of the Aid received (current US$) in Yemen, Rep. in 1988 to that in 1990?
Your answer should be very brief. 0.68. What is the ratio of the Aid received (current US$) in Fragile and conflict affected situations in 1988 to that in 1991?
Your answer should be compact. 0.82. What is the ratio of the Aid received (current US$) of Sub-Saharan Africa (all income levels) in 1988 to that in 1991?
Make the answer very short. 0.81. What is the ratio of the Aid received (current US$) of Yemen, Rep. in 1988 to that in 1991?
Make the answer very short. 1.03. What is the ratio of the Aid received (current US$) of Fragile and conflict affected situations in 1988 to that in 1992?
Give a very brief answer. 0.92. What is the ratio of the Aid received (current US$) of Sub-Saharan Africa (all income levels) in 1988 to that in 1992?
Ensure brevity in your answer.  0.75. What is the ratio of the Aid received (current US$) of Yemen, Rep. in 1988 to that in 1992?
Ensure brevity in your answer.  1.2. What is the ratio of the Aid received (current US$) of Fragile and conflict affected situations in 1988 to that in 1993?
Your answer should be compact. 0.91. What is the ratio of the Aid received (current US$) of Sub-Saharan Africa (all income levels) in 1988 to that in 1993?
Offer a very short reply. 0.84. What is the ratio of the Aid received (current US$) of Fragile and conflict affected situations in 1989 to that in 1990?
Your answer should be very brief. 0.74. What is the ratio of the Aid received (current US$) of Sub-Saharan Africa (all income levels) in 1989 to that in 1990?
Keep it short and to the point. 0.87. What is the ratio of the Aid received (current US$) in Yemen, Rep. in 1989 to that in 1990?
Provide a short and direct response. 0.83. What is the ratio of the Aid received (current US$) of Fragile and conflict affected situations in 1989 to that in 1991?
Make the answer very short. 0.8. What is the ratio of the Aid received (current US$) in Sub-Saharan Africa (all income levels) in 1989 to that in 1991?
Ensure brevity in your answer.  0.87. What is the ratio of the Aid received (current US$) in Yemen, Rep. in 1989 to that in 1991?
Your response must be concise. 1.26. What is the ratio of the Aid received (current US$) of Fragile and conflict affected situations in 1989 to that in 1992?
Your response must be concise. 0.9. What is the ratio of the Aid received (current US$) in Sub-Saharan Africa (all income levels) in 1989 to that in 1992?
Provide a short and direct response. 0.81. What is the ratio of the Aid received (current US$) of Yemen, Rep. in 1989 to that in 1992?
Provide a short and direct response. 1.47. What is the ratio of the Aid received (current US$) in Fragile and conflict affected situations in 1989 to that in 1993?
Your answer should be very brief. 0.89. What is the ratio of the Aid received (current US$) in Sub-Saharan Africa (all income levels) in 1989 to that in 1993?
Offer a very short reply. 0.89. What is the ratio of the Aid received (current US$) in Yemen, Rep. in 1989 to that in 1993?
Your answer should be compact. 1.2. What is the ratio of the Aid received (current US$) in Fragile and conflict affected situations in 1990 to that in 1991?
Offer a terse response. 1.08. What is the ratio of the Aid received (current US$) of Sub-Saharan Africa (all income levels) in 1990 to that in 1991?
Ensure brevity in your answer.  1. What is the ratio of the Aid received (current US$) in Yemen, Rep. in 1990 to that in 1991?
Your response must be concise. 1.52. What is the ratio of the Aid received (current US$) in Fragile and conflict affected situations in 1990 to that in 1992?
Offer a terse response. 1.21. What is the ratio of the Aid received (current US$) of Sub-Saharan Africa (all income levels) in 1990 to that in 1992?
Your answer should be very brief. 0.93. What is the ratio of the Aid received (current US$) of Yemen, Rep. in 1990 to that in 1992?
Provide a short and direct response. 1.77. What is the ratio of the Aid received (current US$) of Fragile and conflict affected situations in 1990 to that in 1993?
Provide a short and direct response. 1.2. What is the ratio of the Aid received (current US$) of Sub-Saharan Africa (all income levels) in 1990 to that in 1993?
Make the answer very short. 1.03. What is the ratio of the Aid received (current US$) in Yemen, Rep. in 1990 to that in 1993?
Offer a very short reply. 1.44. What is the ratio of the Aid received (current US$) in Fragile and conflict affected situations in 1991 to that in 1992?
Keep it short and to the point. 1.13. What is the ratio of the Aid received (current US$) of Sub-Saharan Africa (all income levels) in 1991 to that in 1992?
Ensure brevity in your answer.  0.93. What is the ratio of the Aid received (current US$) in Yemen, Rep. in 1991 to that in 1992?
Keep it short and to the point. 1.17. What is the ratio of the Aid received (current US$) of Fragile and conflict affected situations in 1991 to that in 1993?
Your response must be concise. 1.11. What is the ratio of the Aid received (current US$) of Sub-Saharan Africa (all income levels) in 1991 to that in 1993?
Provide a succinct answer. 1.03. What is the ratio of the Aid received (current US$) in Yemen, Rep. in 1991 to that in 1993?
Your response must be concise. 0.95. What is the ratio of the Aid received (current US$) in Fragile and conflict affected situations in 1992 to that in 1993?
Make the answer very short. 0.99. What is the ratio of the Aid received (current US$) in Sub-Saharan Africa (all income levels) in 1992 to that in 1993?
Your response must be concise. 1.11. What is the ratio of the Aid received (current US$) in Yemen, Rep. in 1992 to that in 1993?
Make the answer very short. 0.81. What is the difference between the highest and the second highest Aid received (current US$) in Fragile and conflict affected situations?
Your answer should be compact. 5.70e+08. What is the difference between the highest and the second highest Aid received (current US$) in Sub-Saharan Africa (all income levels)?
Your answer should be compact. 1.38e+09. What is the difference between the highest and the second highest Aid received (current US$) in Yemen, Rep.?
Your response must be concise. 3.89e+07. What is the difference between the highest and the lowest Aid received (current US$) of Fragile and conflict affected situations?
Your answer should be very brief. 2.08e+09. What is the difference between the highest and the lowest Aid received (current US$) of Sub-Saharan Africa (all income levels)?
Provide a succinct answer. 8.21e+09. What is the difference between the highest and the lowest Aid received (current US$) of Yemen, Rep.?
Your response must be concise. 2.35e+08. 